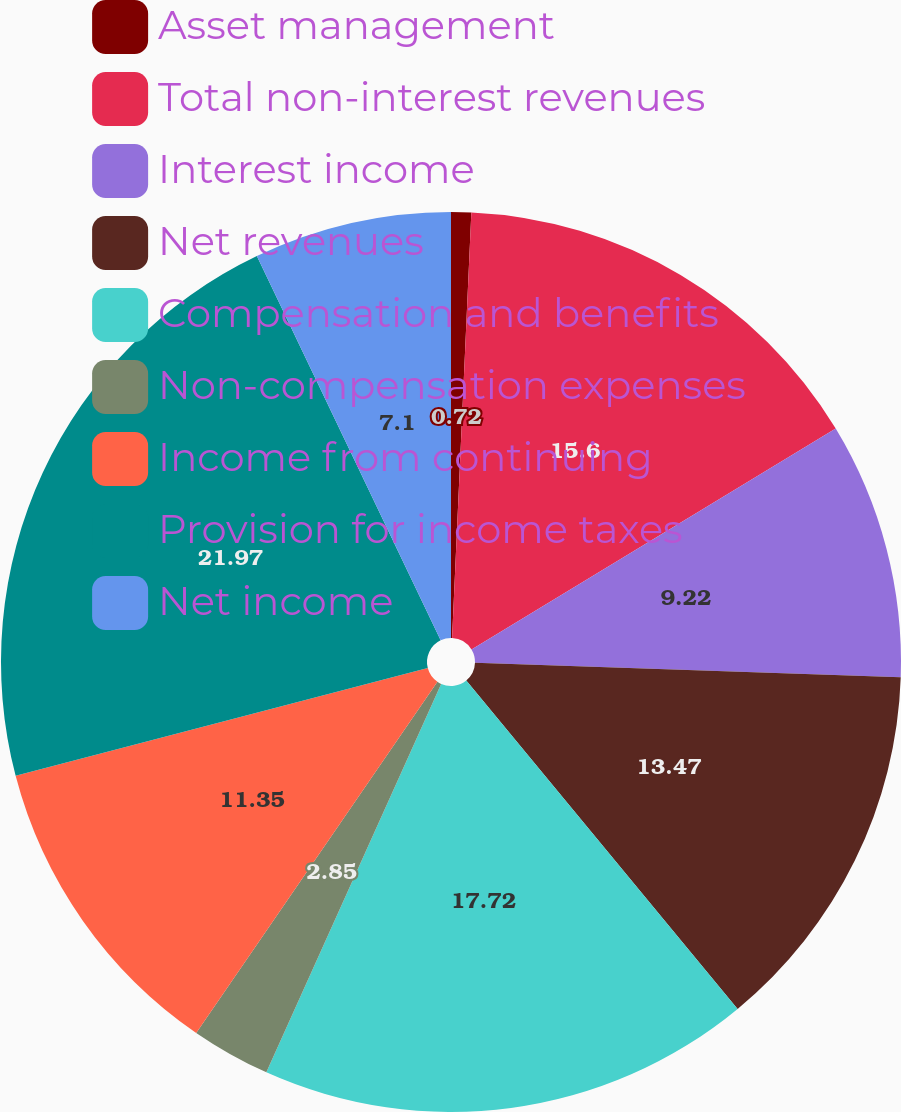<chart> <loc_0><loc_0><loc_500><loc_500><pie_chart><fcel>Asset management<fcel>Total non-interest revenues<fcel>Interest income<fcel>Net revenues<fcel>Compensation and benefits<fcel>Non-compensation expenses<fcel>Income from continuing<fcel>Provision for income taxes<fcel>Net income<nl><fcel>0.72%<fcel>15.6%<fcel>9.22%<fcel>13.47%<fcel>17.72%<fcel>2.85%<fcel>11.35%<fcel>21.97%<fcel>7.1%<nl></chart> 